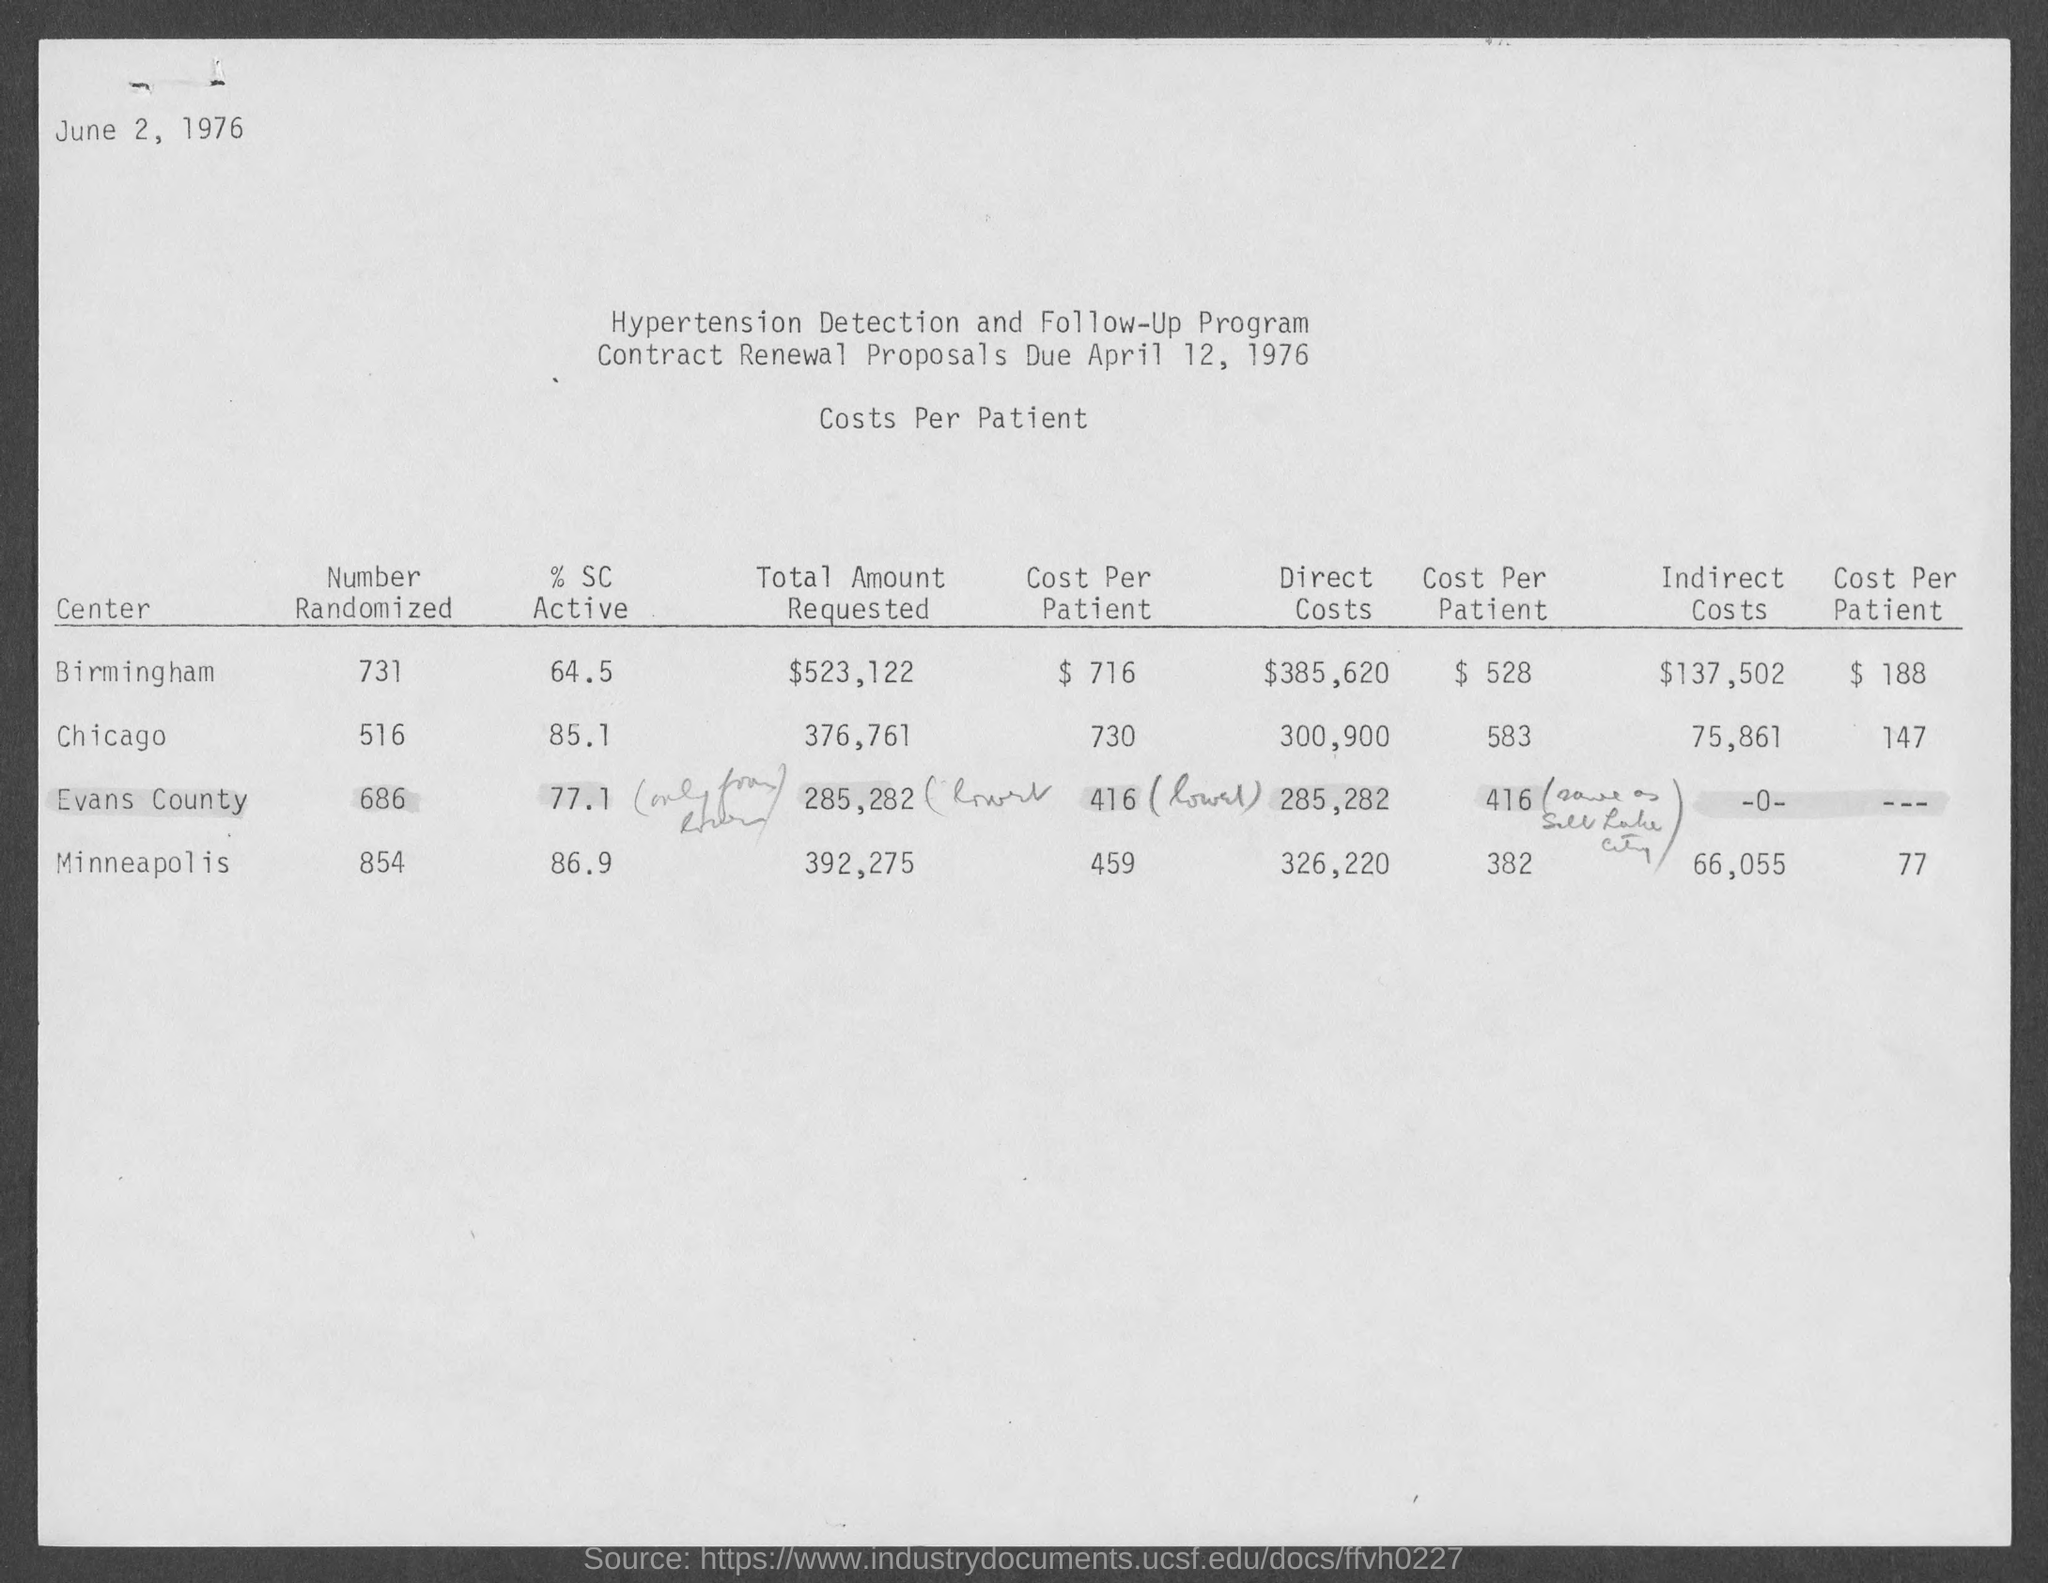When is the document dated?
Your answer should be very brief. June 2, 1976. What is the title of the table?
Your response must be concise. Costs Per Patient. What is the program name?
Provide a succinct answer. Hypertension Detection and Follow-Up Program. When is the contract renewal proposals due?
Your response must be concise. April 12, 1976. What is the total amount requested in the center Birmingham?
Your answer should be very brief. $523,122. What is the % SC Active corresponding to Chicago?
Give a very brief answer. 85.1. What is the number randomized corresponding to Minneapolis?
Your answer should be very brief. 854. Which center has $ 66,055 as the indirect costs?
Keep it short and to the point. Minneapolis. 